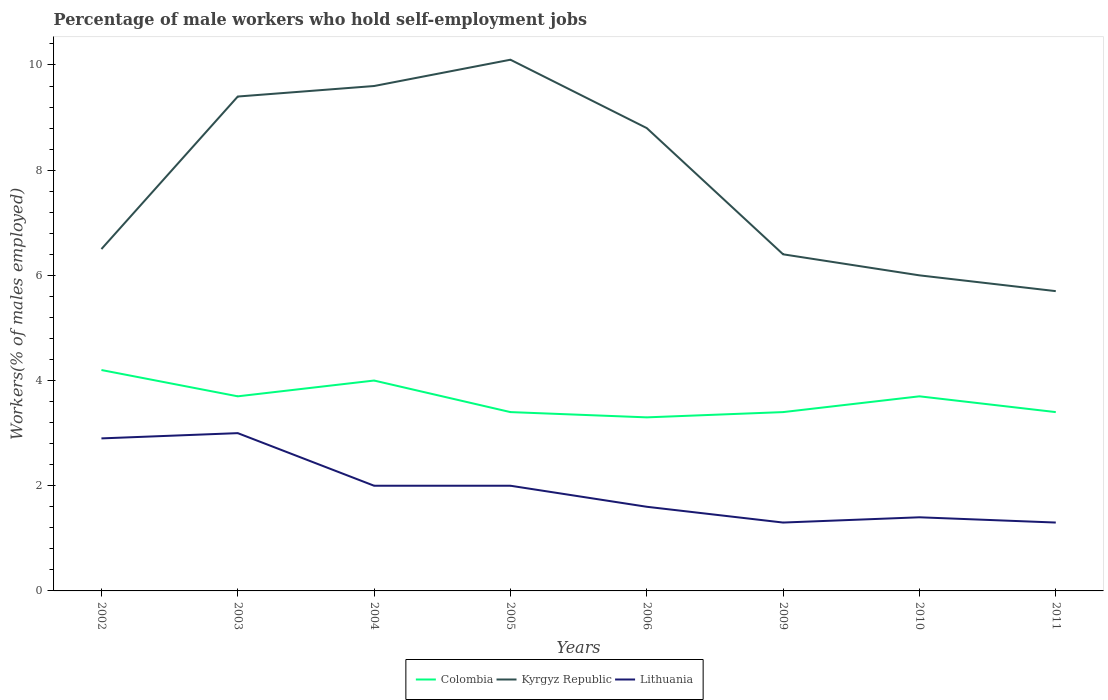Is the number of lines equal to the number of legend labels?
Make the answer very short. Yes. Across all years, what is the maximum percentage of self-employed male workers in Lithuania?
Give a very brief answer. 1.3. In which year was the percentage of self-employed male workers in Kyrgyz Republic maximum?
Keep it short and to the point. 2011. What is the total percentage of self-employed male workers in Lithuania in the graph?
Ensure brevity in your answer.  1.6. What is the difference between the highest and the second highest percentage of self-employed male workers in Lithuania?
Offer a terse response. 1.7. What is the difference between the highest and the lowest percentage of self-employed male workers in Colombia?
Ensure brevity in your answer.  4. Is the percentage of self-employed male workers in Kyrgyz Republic strictly greater than the percentage of self-employed male workers in Colombia over the years?
Provide a succinct answer. No. How many lines are there?
Provide a short and direct response. 3. How many years are there in the graph?
Keep it short and to the point. 8. Does the graph contain any zero values?
Provide a short and direct response. No. Does the graph contain grids?
Your response must be concise. No. Where does the legend appear in the graph?
Provide a succinct answer. Bottom center. How many legend labels are there?
Provide a succinct answer. 3. How are the legend labels stacked?
Your response must be concise. Horizontal. What is the title of the graph?
Give a very brief answer. Percentage of male workers who hold self-employment jobs. What is the label or title of the X-axis?
Offer a terse response. Years. What is the label or title of the Y-axis?
Your response must be concise. Workers(% of males employed). What is the Workers(% of males employed) in Colombia in 2002?
Your answer should be compact. 4.2. What is the Workers(% of males employed) in Kyrgyz Republic in 2002?
Offer a very short reply. 6.5. What is the Workers(% of males employed) in Lithuania in 2002?
Offer a very short reply. 2.9. What is the Workers(% of males employed) in Colombia in 2003?
Your response must be concise. 3.7. What is the Workers(% of males employed) of Kyrgyz Republic in 2003?
Your response must be concise. 9.4. What is the Workers(% of males employed) in Lithuania in 2003?
Keep it short and to the point. 3. What is the Workers(% of males employed) of Colombia in 2004?
Offer a terse response. 4. What is the Workers(% of males employed) in Kyrgyz Republic in 2004?
Provide a succinct answer. 9.6. What is the Workers(% of males employed) in Lithuania in 2004?
Offer a terse response. 2. What is the Workers(% of males employed) in Colombia in 2005?
Offer a terse response. 3.4. What is the Workers(% of males employed) in Kyrgyz Republic in 2005?
Provide a succinct answer. 10.1. What is the Workers(% of males employed) of Lithuania in 2005?
Give a very brief answer. 2. What is the Workers(% of males employed) in Colombia in 2006?
Make the answer very short. 3.3. What is the Workers(% of males employed) of Kyrgyz Republic in 2006?
Make the answer very short. 8.8. What is the Workers(% of males employed) of Lithuania in 2006?
Your answer should be very brief. 1.6. What is the Workers(% of males employed) of Colombia in 2009?
Your answer should be compact. 3.4. What is the Workers(% of males employed) in Kyrgyz Republic in 2009?
Ensure brevity in your answer.  6.4. What is the Workers(% of males employed) of Lithuania in 2009?
Provide a succinct answer. 1.3. What is the Workers(% of males employed) of Colombia in 2010?
Ensure brevity in your answer.  3.7. What is the Workers(% of males employed) of Lithuania in 2010?
Ensure brevity in your answer.  1.4. What is the Workers(% of males employed) of Colombia in 2011?
Your answer should be very brief. 3.4. What is the Workers(% of males employed) of Kyrgyz Republic in 2011?
Make the answer very short. 5.7. What is the Workers(% of males employed) in Lithuania in 2011?
Keep it short and to the point. 1.3. Across all years, what is the maximum Workers(% of males employed) of Colombia?
Keep it short and to the point. 4.2. Across all years, what is the maximum Workers(% of males employed) in Kyrgyz Republic?
Your answer should be compact. 10.1. Across all years, what is the minimum Workers(% of males employed) of Colombia?
Offer a very short reply. 3.3. Across all years, what is the minimum Workers(% of males employed) of Kyrgyz Republic?
Your response must be concise. 5.7. Across all years, what is the minimum Workers(% of males employed) in Lithuania?
Offer a very short reply. 1.3. What is the total Workers(% of males employed) of Colombia in the graph?
Your response must be concise. 29.1. What is the total Workers(% of males employed) in Kyrgyz Republic in the graph?
Your response must be concise. 62.5. What is the total Workers(% of males employed) in Lithuania in the graph?
Offer a very short reply. 15.5. What is the difference between the Workers(% of males employed) in Kyrgyz Republic in 2002 and that in 2003?
Your response must be concise. -2.9. What is the difference between the Workers(% of males employed) in Colombia in 2002 and that in 2004?
Offer a very short reply. 0.2. What is the difference between the Workers(% of males employed) in Lithuania in 2002 and that in 2004?
Ensure brevity in your answer.  0.9. What is the difference between the Workers(% of males employed) in Colombia in 2002 and that in 2005?
Offer a terse response. 0.8. What is the difference between the Workers(% of males employed) of Colombia in 2002 and that in 2006?
Your answer should be very brief. 0.9. What is the difference between the Workers(% of males employed) of Colombia in 2002 and that in 2009?
Provide a short and direct response. 0.8. What is the difference between the Workers(% of males employed) in Kyrgyz Republic in 2002 and that in 2009?
Ensure brevity in your answer.  0.1. What is the difference between the Workers(% of males employed) of Lithuania in 2002 and that in 2010?
Offer a very short reply. 1.5. What is the difference between the Workers(% of males employed) of Colombia in 2002 and that in 2011?
Your answer should be very brief. 0.8. What is the difference between the Workers(% of males employed) in Kyrgyz Republic in 2002 and that in 2011?
Ensure brevity in your answer.  0.8. What is the difference between the Workers(% of males employed) in Lithuania in 2002 and that in 2011?
Give a very brief answer. 1.6. What is the difference between the Workers(% of males employed) of Kyrgyz Republic in 2003 and that in 2004?
Your answer should be compact. -0.2. What is the difference between the Workers(% of males employed) in Lithuania in 2003 and that in 2004?
Make the answer very short. 1. What is the difference between the Workers(% of males employed) of Colombia in 2003 and that in 2005?
Your response must be concise. 0.3. What is the difference between the Workers(% of males employed) of Lithuania in 2003 and that in 2005?
Keep it short and to the point. 1. What is the difference between the Workers(% of males employed) of Colombia in 2003 and that in 2006?
Offer a terse response. 0.4. What is the difference between the Workers(% of males employed) of Kyrgyz Republic in 2003 and that in 2006?
Ensure brevity in your answer.  0.6. What is the difference between the Workers(% of males employed) in Lithuania in 2003 and that in 2006?
Ensure brevity in your answer.  1.4. What is the difference between the Workers(% of males employed) of Colombia in 2003 and that in 2009?
Offer a very short reply. 0.3. What is the difference between the Workers(% of males employed) in Kyrgyz Republic in 2003 and that in 2009?
Keep it short and to the point. 3. What is the difference between the Workers(% of males employed) of Colombia in 2003 and that in 2010?
Your answer should be very brief. 0. What is the difference between the Workers(% of males employed) of Kyrgyz Republic in 2003 and that in 2010?
Make the answer very short. 3.4. What is the difference between the Workers(% of males employed) of Lithuania in 2003 and that in 2010?
Provide a short and direct response. 1.6. What is the difference between the Workers(% of males employed) in Colombia in 2003 and that in 2011?
Give a very brief answer. 0.3. What is the difference between the Workers(% of males employed) in Kyrgyz Republic in 2003 and that in 2011?
Provide a succinct answer. 3.7. What is the difference between the Workers(% of males employed) of Lithuania in 2003 and that in 2011?
Your response must be concise. 1.7. What is the difference between the Workers(% of males employed) in Lithuania in 2004 and that in 2005?
Offer a terse response. 0. What is the difference between the Workers(% of males employed) in Colombia in 2004 and that in 2006?
Provide a short and direct response. 0.7. What is the difference between the Workers(% of males employed) in Kyrgyz Republic in 2004 and that in 2006?
Keep it short and to the point. 0.8. What is the difference between the Workers(% of males employed) in Lithuania in 2004 and that in 2006?
Keep it short and to the point. 0.4. What is the difference between the Workers(% of males employed) in Colombia in 2004 and that in 2010?
Keep it short and to the point. 0.3. What is the difference between the Workers(% of males employed) in Kyrgyz Republic in 2004 and that in 2010?
Offer a very short reply. 3.6. What is the difference between the Workers(% of males employed) of Lithuania in 2004 and that in 2011?
Offer a terse response. 0.7. What is the difference between the Workers(% of males employed) of Kyrgyz Republic in 2005 and that in 2006?
Provide a succinct answer. 1.3. What is the difference between the Workers(% of males employed) of Lithuania in 2005 and that in 2009?
Your answer should be very brief. 0.7. What is the difference between the Workers(% of males employed) of Kyrgyz Republic in 2005 and that in 2010?
Your answer should be compact. 4.1. What is the difference between the Workers(% of males employed) of Lithuania in 2005 and that in 2010?
Offer a very short reply. 0.6. What is the difference between the Workers(% of males employed) in Lithuania in 2005 and that in 2011?
Provide a short and direct response. 0.7. What is the difference between the Workers(% of males employed) in Colombia in 2006 and that in 2010?
Your answer should be very brief. -0.4. What is the difference between the Workers(% of males employed) of Colombia in 2006 and that in 2011?
Provide a succinct answer. -0.1. What is the difference between the Workers(% of males employed) in Kyrgyz Republic in 2006 and that in 2011?
Your answer should be compact. 3.1. What is the difference between the Workers(% of males employed) in Colombia in 2009 and that in 2010?
Ensure brevity in your answer.  -0.3. What is the difference between the Workers(% of males employed) of Kyrgyz Republic in 2009 and that in 2010?
Give a very brief answer. 0.4. What is the difference between the Workers(% of males employed) in Colombia in 2009 and that in 2011?
Offer a terse response. 0. What is the difference between the Workers(% of males employed) of Lithuania in 2009 and that in 2011?
Provide a short and direct response. 0. What is the difference between the Workers(% of males employed) in Colombia in 2010 and that in 2011?
Provide a short and direct response. 0.3. What is the difference between the Workers(% of males employed) of Kyrgyz Republic in 2010 and that in 2011?
Give a very brief answer. 0.3. What is the difference between the Workers(% of males employed) in Lithuania in 2010 and that in 2011?
Offer a terse response. 0.1. What is the difference between the Workers(% of males employed) of Colombia in 2002 and the Workers(% of males employed) of Kyrgyz Republic in 2003?
Your response must be concise. -5.2. What is the difference between the Workers(% of males employed) in Colombia in 2002 and the Workers(% of males employed) in Kyrgyz Republic in 2004?
Your answer should be very brief. -5.4. What is the difference between the Workers(% of males employed) of Kyrgyz Republic in 2002 and the Workers(% of males employed) of Lithuania in 2004?
Your answer should be very brief. 4.5. What is the difference between the Workers(% of males employed) of Colombia in 2002 and the Workers(% of males employed) of Kyrgyz Republic in 2005?
Your answer should be compact. -5.9. What is the difference between the Workers(% of males employed) of Colombia in 2002 and the Workers(% of males employed) of Kyrgyz Republic in 2006?
Your answer should be very brief. -4.6. What is the difference between the Workers(% of males employed) in Colombia in 2002 and the Workers(% of males employed) in Lithuania in 2006?
Your response must be concise. 2.6. What is the difference between the Workers(% of males employed) in Kyrgyz Republic in 2002 and the Workers(% of males employed) in Lithuania in 2006?
Keep it short and to the point. 4.9. What is the difference between the Workers(% of males employed) in Colombia in 2002 and the Workers(% of males employed) in Lithuania in 2009?
Offer a terse response. 2.9. What is the difference between the Workers(% of males employed) of Kyrgyz Republic in 2002 and the Workers(% of males employed) of Lithuania in 2009?
Your answer should be compact. 5.2. What is the difference between the Workers(% of males employed) of Colombia in 2002 and the Workers(% of males employed) of Kyrgyz Republic in 2010?
Provide a short and direct response. -1.8. What is the difference between the Workers(% of males employed) in Colombia in 2002 and the Workers(% of males employed) in Lithuania in 2010?
Give a very brief answer. 2.8. What is the difference between the Workers(% of males employed) of Kyrgyz Republic in 2002 and the Workers(% of males employed) of Lithuania in 2010?
Your answer should be compact. 5.1. What is the difference between the Workers(% of males employed) of Kyrgyz Republic in 2003 and the Workers(% of males employed) of Lithuania in 2004?
Give a very brief answer. 7.4. What is the difference between the Workers(% of males employed) of Kyrgyz Republic in 2003 and the Workers(% of males employed) of Lithuania in 2009?
Ensure brevity in your answer.  8.1. What is the difference between the Workers(% of males employed) of Colombia in 2003 and the Workers(% of males employed) of Kyrgyz Republic in 2010?
Give a very brief answer. -2.3. What is the difference between the Workers(% of males employed) in Kyrgyz Republic in 2003 and the Workers(% of males employed) in Lithuania in 2010?
Your answer should be very brief. 8. What is the difference between the Workers(% of males employed) of Colombia in 2003 and the Workers(% of males employed) of Lithuania in 2011?
Make the answer very short. 2.4. What is the difference between the Workers(% of males employed) in Colombia in 2004 and the Workers(% of males employed) in Lithuania in 2005?
Offer a very short reply. 2. What is the difference between the Workers(% of males employed) of Kyrgyz Republic in 2004 and the Workers(% of males employed) of Lithuania in 2005?
Keep it short and to the point. 7.6. What is the difference between the Workers(% of males employed) in Colombia in 2004 and the Workers(% of males employed) in Kyrgyz Republic in 2009?
Offer a very short reply. -2.4. What is the difference between the Workers(% of males employed) of Kyrgyz Republic in 2004 and the Workers(% of males employed) of Lithuania in 2009?
Your answer should be compact. 8.3. What is the difference between the Workers(% of males employed) of Colombia in 2004 and the Workers(% of males employed) of Kyrgyz Republic in 2010?
Your response must be concise. -2. What is the difference between the Workers(% of males employed) in Kyrgyz Republic in 2004 and the Workers(% of males employed) in Lithuania in 2010?
Provide a short and direct response. 8.2. What is the difference between the Workers(% of males employed) of Colombia in 2004 and the Workers(% of males employed) of Lithuania in 2011?
Provide a succinct answer. 2.7. What is the difference between the Workers(% of males employed) of Kyrgyz Republic in 2004 and the Workers(% of males employed) of Lithuania in 2011?
Your answer should be compact. 8.3. What is the difference between the Workers(% of males employed) in Colombia in 2005 and the Workers(% of males employed) in Lithuania in 2006?
Keep it short and to the point. 1.8. What is the difference between the Workers(% of males employed) of Colombia in 2005 and the Workers(% of males employed) of Kyrgyz Republic in 2009?
Offer a very short reply. -3. What is the difference between the Workers(% of males employed) of Colombia in 2005 and the Workers(% of males employed) of Lithuania in 2009?
Give a very brief answer. 2.1. What is the difference between the Workers(% of males employed) in Kyrgyz Republic in 2005 and the Workers(% of males employed) in Lithuania in 2009?
Your answer should be compact. 8.8. What is the difference between the Workers(% of males employed) of Colombia in 2005 and the Workers(% of males employed) of Kyrgyz Republic in 2010?
Provide a short and direct response. -2.6. What is the difference between the Workers(% of males employed) in Colombia in 2005 and the Workers(% of males employed) in Lithuania in 2010?
Your response must be concise. 2. What is the difference between the Workers(% of males employed) of Colombia in 2005 and the Workers(% of males employed) of Kyrgyz Republic in 2011?
Keep it short and to the point. -2.3. What is the difference between the Workers(% of males employed) in Colombia in 2005 and the Workers(% of males employed) in Lithuania in 2011?
Provide a succinct answer. 2.1. What is the difference between the Workers(% of males employed) of Colombia in 2006 and the Workers(% of males employed) of Kyrgyz Republic in 2009?
Make the answer very short. -3.1. What is the difference between the Workers(% of males employed) of Kyrgyz Republic in 2006 and the Workers(% of males employed) of Lithuania in 2009?
Make the answer very short. 7.5. What is the difference between the Workers(% of males employed) in Colombia in 2006 and the Workers(% of males employed) in Lithuania in 2010?
Provide a short and direct response. 1.9. What is the difference between the Workers(% of males employed) in Colombia in 2006 and the Workers(% of males employed) in Lithuania in 2011?
Keep it short and to the point. 2. What is the difference between the Workers(% of males employed) in Colombia in 2009 and the Workers(% of males employed) in Lithuania in 2011?
Make the answer very short. 2.1. What is the difference between the Workers(% of males employed) in Kyrgyz Republic in 2009 and the Workers(% of males employed) in Lithuania in 2011?
Make the answer very short. 5.1. What is the difference between the Workers(% of males employed) of Colombia in 2010 and the Workers(% of males employed) of Lithuania in 2011?
Ensure brevity in your answer.  2.4. What is the difference between the Workers(% of males employed) of Kyrgyz Republic in 2010 and the Workers(% of males employed) of Lithuania in 2011?
Provide a short and direct response. 4.7. What is the average Workers(% of males employed) in Colombia per year?
Give a very brief answer. 3.64. What is the average Workers(% of males employed) of Kyrgyz Republic per year?
Your response must be concise. 7.81. What is the average Workers(% of males employed) of Lithuania per year?
Give a very brief answer. 1.94. In the year 2002, what is the difference between the Workers(% of males employed) of Kyrgyz Republic and Workers(% of males employed) of Lithuania?
Your answer should be very brief. 3.6. In the year 2003, what is the difference between the Workers(% of males employed) of Colombia and Workers(% of males employed) of Lithuania?
Your answer should be compact. 0.7. In the year 2003, what is the difference between the Workers(% of males employed) of Kyrgyz Republic and Workers(% of males employed) of Lithuania?
Ensure brevity in your answer.  6.4. In the year 2004, what is the difference between the Workers(% of males employed) in Kyrgyz Republic and Workers(% of males employed) in Lithuania?
Give a very brief answer. 7.6. In the year 2005, what is the difference between the Workers(% of males employed) in Colombia and Workers(% of males employed) in Kyrgyz Republic?
Your answer should be very brief. -6.7. In the year 2005, what is the difference between the Workers(% of males employed) in Kyrgyz Republic and Workers(% of males employed) in Lithuania?
Provide a short and direct response. 8.1. In the year 2006, what is the difference between the Workers(% of males employed) in Kyrgyz Republic and Workers(% of males employed) in Lithuania?
Provide a short and direct response. 7.2. In the year 2009, what is the difference between the Workers(% of males employed) of Colombia and Workers(% of males employed) of Lithuania?
Your answer should be compact. 2.1. In the year 2010, what is the difference between the Workers(% of males employed) of Colombia and Workers(% of males employed) of Kyrgyz Republic?
Provide a succinct answer. -2.3. In the year 2011, what is the difference between the Workers(% of males employed) in Colombia and Workers(% of males employed) in Kyrgyz Republic?
Keep it short and to the point. -2.3. What is the ratio of the Workers(% of males employed) of Colombia in 2002 to that in 2003?
Provide a short and direct response. 1.14. What is the ratio of the Workers(% of males employed) in Kyrgyz Republic in 2002 to that in 2003?
Your response must be concise. 0.69. What is the ratio of the Workers(% of males employed) of Lithuania in 2002 to that in 2003?
Your answer should be compact. 0.97. What is the ratio of the Workers(% of males employed) of Colombia in 2002 to that in 2004?
Keep it short and to the point. 1.05. What is the ratio of the Workers(% of males employed) of Kyrgyz Republic in 2002 to that in 2004?
Offer a very short reply. 0.68. What is the ratio of the Workers(% of males employed) of Lithuania in 2002 to that in 2004?
Keep it short and to the point. 1.45. What is the ratio of the Workers(% of males employed) in Colombia in 2002 to that in 2005?
Offer a very short reply. 1.24. What is the ratio of the Workers(% of males employed) in Kyrgyz Republic in 2002 to that in 2005?
Your response must be concise. 0.64. What is the ratio of the Workers(% of males employed) in Lithuania in 2002 to that in 2005?
Your answer should be compact. 1.45. What is the ratio of the Workers(% of males employed) in Colombia in 2002 to that in 2006?
Make the answer very short. 1.27. What is the ratio of the Workers(% of males employed) in Kyrgyz Republic in 2002 to that in 2006?
Keep it short and to the point. 0.74. What is the ratio of the Workers(% of males employed) of Lithuania in 2002 to that in 2006?
Offer a terse response. 1.81. What is the ratio of the Workers(% of males employed) of Colombia in 2002 to that in 2009?
Give a very brief answer. 1.24. What is the ratio of the Workers(% of males employed) of Kyrgyz Republic in 2002 to that in 2009?
Offer a very short reply. 1.02. What is the ratio of the Workers(% of males employed) of Lithuania in 2002 to that in 2009?
Your answer should be compact. 2.23. What is the ratio of the Workers(% of males employed) in Colombia in 2002 to that in 2010?
Your answer should be very brief. 1.14. What is the ratio of the Workers(% of males employed) of Lithuania in 2002 to that in 2010?
Offer a terse response. 2.07. What is the ratio of the Workers(% of males employed) in Colombia in 2002 to that in 2011?
Provide a succinct answer. 1.24. What is the ratio of the Workers(% of males employed) of Kyrgyz Republic in 2002 to that in 2011?
Give a very brief answer. 1.14. What is the ratio of the Workers(% of males employed) of Lithuania in 2002 to that in 2011?
Provide a short and direct response. 2.23. What is the ratio of the Workers(% of males employed) of Colombia in 2003 to that in 2004?
Ensure brevity in your answer.  0.93. What is the ratio of the Workers(% of males employed) of Kyrgyz Republic in 2003 to that in 2004?
Your answer should be compact. 0.98. What is the ratio of the Workers(% of males employed) of Colombia in 2003 to that in 2005?
Offer a very short reply. 1.09. What is the ratio of the Workers(% of males employed) of Kyrgyz Republic in 2003 to that in 2005?
Offer a very short reply. 0.93. What is the ratio of the Workers(% of males employed) in Colombia in 2003 to that in 2006?
Your answer should be compact. 1.12. What is the ratio of the Workers(% of males employed) of Kyrgyz Republic in 2003 to that in 2006?
Keep it short and to the point. 1.07. What is the ratio of the Workers(% of males employed) in Lithuania in 2003 to that in 2006?
Your answer should be very brief. 1.88. What is the ratio of the Workers(% of males employed) in Colombia in 2003 to that in 2009?
Keep it short and to the point. 1.09. What is the ratio of the Workers(% of males employed) in Kyrgyz Republic in 2003 to that in 2009?
Offer a very short reply. 1.47. What is the ratio of the Workers(% of males employed) in Lithuania in 2003 to that in 2009?
Your answer should be compact. 2.31. What is the ratio of the Workers(% of males employed) of Colombia in 2003 to that in 2010?
Keep it short and to the point. 1. What is the ratio of the Workers(% of males employed) in Kyrgyz Republic in 2003 to that in 2010?
Provide a succinct answer. 1.57. What is the ratio of the Workers(% of males employed) of Lithuania in 2003 to that in 2010?
Offer a very short reply. 2.14. What is the ratio of the Workers(% of males employed) of Colombia in 2003 to that in 2011?
Offer a very short reply. 1.09. What is the ratio of the Workers(% of males employed) of Kyrgyz Republic in 2003 to that in 2011?
Make the answer very short. 1.65. What is the ratio of the Workers(% of males employed) of Lithuania in 2003 to that in 2011?
Give a very brief answer. 2.31. What is the ratio of the Workers(% of males employed) in Colombia in 2004 to that in 2005?
Keep it short and to the point. 1.18. What is the ratio of the Workers(% of males employed) of Kyrgyz Republic in 2004 to that in 2005?
Keep it short and to the point. 0.95. What is the ratio of the Workers(% of males employed) in Lithuania in 2004 to that in 2005?
Ensure brevity in your answer.  1. What is the ratio of the Workers(% of males employed) of Colombia in 2004 to that in 2006?
Your answer should be very brief. 1.21. What is the ratio of the Workers(% of males employed) in Lithuania in 2004 to that in 2006?
Ensure brevity in your answer.  1.25. What is the ratio of the Workers(% of males employed) in Colombia in 2004 to that in 2009?
Your answer should be compact. 1.18. What is the ratio of the Workers(% of males employed) in Kyrgyz Republic in 2004 to that in 2009?
Make the answer very short. 1.5. What is the ratio of the Workers(% of males employed) of Lithuania in 2004 to that in 2009?
Your response must be concise. 1.54. What is the ratio of the Workers(% of males employed) in Colombia in 2004 to that in 2010?
Provide a short and direct response. 1.08. What is the ratio of the Workers(% of males employed) in Kyrgyz Republic in 2004 to that in 2010?
Offer a terse response. 1.6. What is the ratio of the Workers(% of males employed) in Lithuania in 2004 to that in 2010?
Offer a very short reply. 1.43. What is the ratio of the Workers(% of males employed) in Colombia in 2004 to that in 2011?
Offer a terse response. 1.18. What is the ratio of the Workers(% of males employed) of Kyrgyz Republic in 2004 to that in 2011?
Give a very brief answer. 1.68. What is the ratio of the Workers(% of males employed) of Lithuania in 2004 to that in 2011?
Offer a terse response. 1.54. What is the ratio of the Workers(% of males employed) of Colombia in 2005 to that in 2006?
Your answer should be compact. 1.03. What is the ratio of the Workers(% of males employed) of Kyrgyz Republic in 2005 to that in 2006?
Offer a terse response. 1.15. What is the ratio of the Workers(% of males employed) in Kyrgyz Republic in 2005 to that in 2009?
Provide a succinct answer. 1.58. What is the ratio of the Workers(% of males employed) in Lithuania in 2005 to that in 2009?
Your answer should be compact. 1.54. What is the ratio of the Workers(% of males employed) in Colombia in 2005 to that in 2010?
Offer a very short reply. 0.92. What is the ratio of the Workers(% of males employed) of Kyrgyz Republic in 2005 to that in 2010?
Offer a very short reply. 1.68. What is the ratio of the Workers(% of males employed) in Lithuania in 2005 to that in 2010?
Your response must be concise. 1.43. What is the ratio of the Workers(% of males employed) in Colombia in 2005 to that in 2011?
Your answer should be compact. 1. What is the ratio of the Workers(% of males employed) in Kyrgyz Republic in 2005 to that in 2011?
Ensure brevity in your answer.  1.77. What is the ratio of the Workers(% of males employed) of Lithuania in 2005 to that in 2011?
Your response must be concise. 1.54. What is the ratio of the Workers(% of males employed) in Colombia in 2006 to that in 2009?
Your response must be concise. 0.97. What is the ratio of the Workers(% of males employed) in Kyrgyz Republic in 2006 to that in 2009?
Provide a succinct answer. 1.38. What is the ratio of the Workers(% of males employed) of Lithuania in 2006 to that in 2009?
Offer a terse response. 1.23. What is the ratio of the Workers(% of males employed) of Colombia in 2006 to that in 2010?
Provide a short and direct response. 0.89. What is the ratio of the Workers(% of males employed) of Kyrgyz Republic in 2006 to that in 2010?
Make the answer very short. 1.47. What is the ratio of the Workers(% of males employed) in Lithuania in 2006 to that in 2010?
Keep it short and to the point. 1.14. What is the ratio of the Workers(% of males employed) of Colombia in 2006 to that in 2011?
Offer a terse response. 0.97. What is the ratio of the Workers(% of males employed) in Kyrgyz Republic in 2006 to that in 2011?
Your answer should be very brief. 1.54. What is the ratio of the Workers(% of males employed) in Lithuania in 2006 to that in 2011?
Give a very brief answer. 1.23. What is the ratio of the Workers(% of males employed) of Colombia in 2009 to that in 2010?
Keep it short and to the point. 0.92. What is the ratio of the Workers(% of males employed) in Kyrgyz Republic in 2009 to that in 2010?
Keep it short and to the point. 1.07. What is the ratio of the Workers(% of males employed) in Lithuania in 2009 to that in 2010?
Provide a succinct answer. 0.93. What is the ratio of the Workers(% of males employed) of Kyrgyz Republic in 2009 to that in 2011?
Your answer should be very brief. 1.12. What is the ratio of the Workers(% of males employed) in Lithuania in 2009 to that in 2011?
Make the answer very short. 1. What is the ratio of the Workers(% of males employed) in Colombia in 2010 to that in 2011?
Give a very brief answer. 1.09. What is the ratio of the Workers(% of males employed) of Kyrgyz Republic in 2010 to that in 2011?
Keep it short and to the point. 1.05. What is the difference between the highest and the second highest Workers(% of males employed) of Colombia?
Offer a very short reply. 0.2. What is the difference between the highest and the second highest Workers(% of males employed) in Kyrgyz Republic?
Your answer should be very brief. 0.5. What is the difference between the highest and the second highest Workers(% of males employed) of Lithuania?
Offer a very short reply. 0.1. 